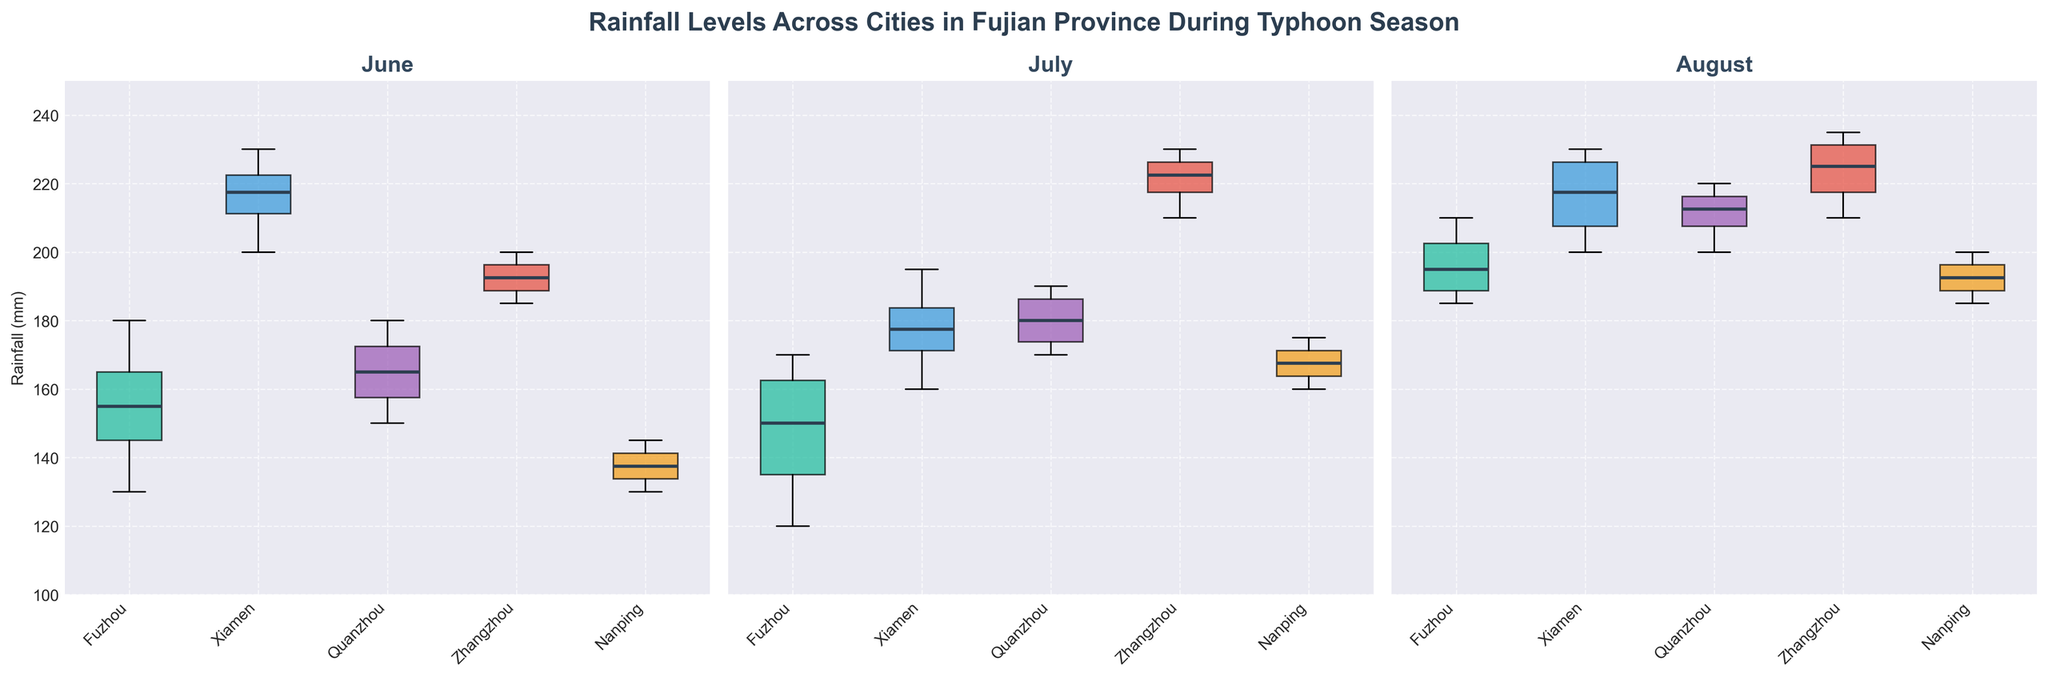What cities are compared in the figure? The figure compares rainfall levels across different cities. The x-axis labels on each subplot indicate which cities are included.
Answer: Fuzhou, Xiamen, Quanzhou, Zhangzhou, Nanping What is the range of rainfall values for Fuzhou in June? Observing the box plot for June, the edges of the box plot (whiskers) and the outliers define the range for Fuzhou. The minimum whisker is at 130 mm and the maximum whisker is around 180 mm.
Answer: 130-180 mm Which city experienced the highest median rainfall in August? Reviewing the box plot for August, the central line of each box (median) has to be compared among all the cities. Xiamen's median is the highest, nearing the 220 mm mark.
Answer: Xiamen In which month does Zhangzhou have the greatest variability in rainfall? To find the variability, check the length of the whiskers and the interquartile range (IQR) in each of Zhangzhou's box plots. Zhangzhou has the widest range in July, indicating the greatest variability.
Answer: July Which month has the largest interquartile range (IQR) for Quanzhou? The IQR is indicated by the height of the box. By comparing the height of Quanzhou's boxes across different months, the box plot for August shows the largest IQR.
Answer: August How does the median rainfall in Fuzhou change from June to July? By examining the central line of the boxes representing Fuzhou, the median decreases from June (around 165 mm) to July (around 145 mm).
Answer: Decreases Is there a city that consistently has lower rainfall compared to others across all months? Looking at all the box plots for each month, check which city has lower whiskers and medians. Nanping generally appears to have the lowest range and median in each month.
Answer: Nanping Which city has the highest upper whisker in June? The upper whisker represents the maximum non-outlier value. Xiamen's upper whisker, nearing 230 mm, is the highest among the cities in June.
Answer: Xiamen Does any city show a significant outlier in July, and if so, which one? Notice the presence of 'D' markers indicative of outliers in July. Zhangzhou shows a significant outlier larger than 220 mm.
Answer: Zhangzhou 